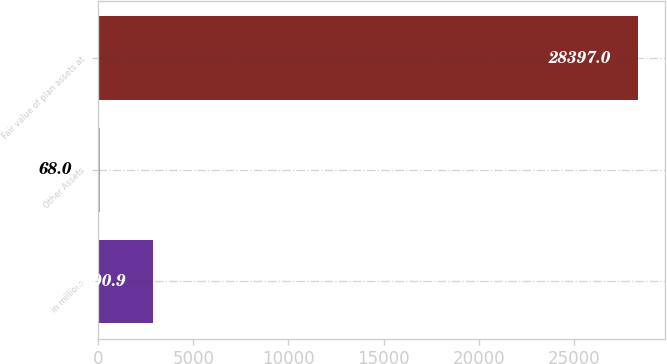Convert chart. <chart><loc_0><loc_0><loc_500><loc_500><bar_chart><fcel>in millions<fcel>Other Assets<fcel>Fair value of plan assets at<nl><fcel>2900.9<fcel>68<fcel>28397<nl></chart> 